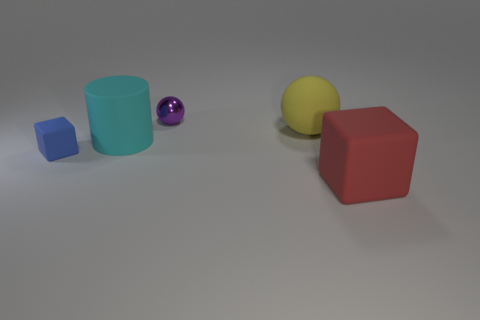Add 4 cyan cylinders. How many objects exist? 9 Subtract all balls. How many objects are left? 3 Subtract 0 brown blocks. How many objects are left? 5 Subtract all small shiny things. Subtract all balls. How many objects are left? 2 Add 4 yellow spheres. How many yellow spheres are left? 5 Add 3 large gray cylinders. How many large gray cylinders exist? 3 